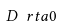<formula> <loc_0><loc_0><loc_500><loc_500>D \ r t a 0</formula> 